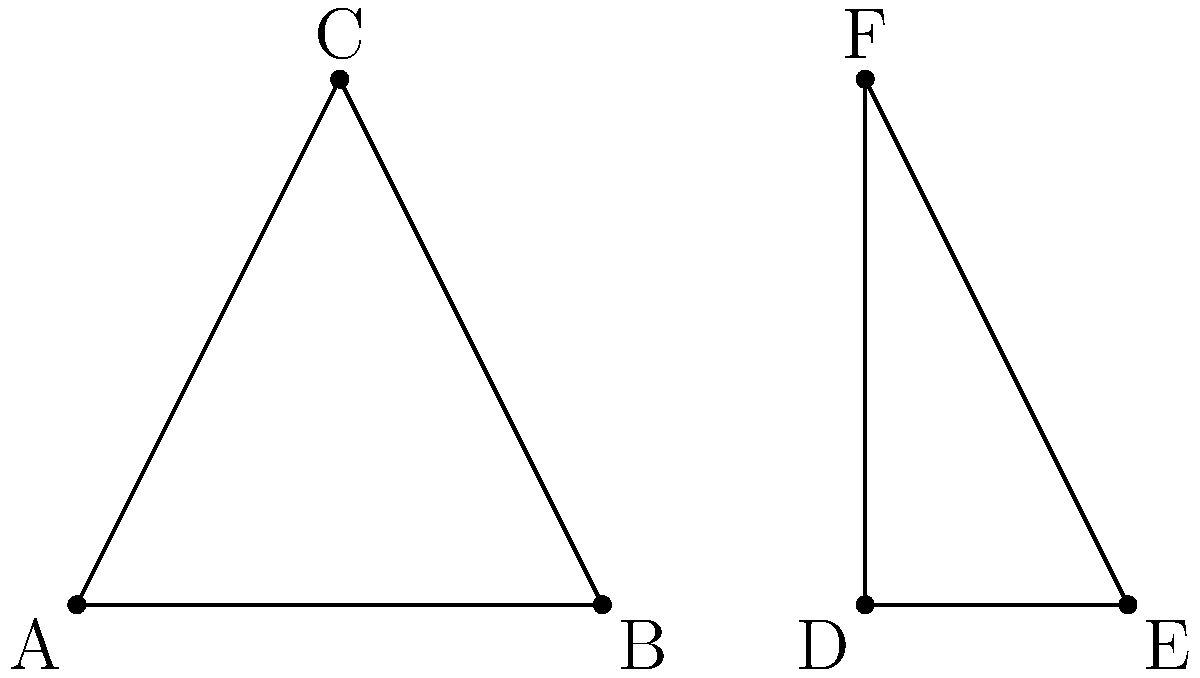In the figure above, triangle ABC is reflected across the blue dashed line to create triangle DEF. If the coordinates of point C are (1,2), what are the coordinates of point F? To solve this problem, we need to understand the concept of reflection symmetry:

1. In a reflection, each point is mapped to a point that is the same distance from the line of reflection but on the opposite side.

2. The blue dashed line is the line of reflection, which appears to be a vertical line halfway between the two triangles.

3. We can deduce that this line of reflection is at x = 1.5, as it's exactly in the middle of the two triangles.

4. To find the coordinates of F, we need to reflect point C across this line.

5. The x-coordinate of C is 1. The distance from x = 1 to the line of reflection (x = 1.5) is 0.5.

6. In a reflection, this distance is preserved on the other side of the line. So, the x-coordinate of F will be 1.5 + 0.5 = 2.

7. The y-coordinate remains unchanged in a reflection across a vertical line.

Therefore, if C is at (1,2), F will be at (3,2).
Answer: (3,2) 